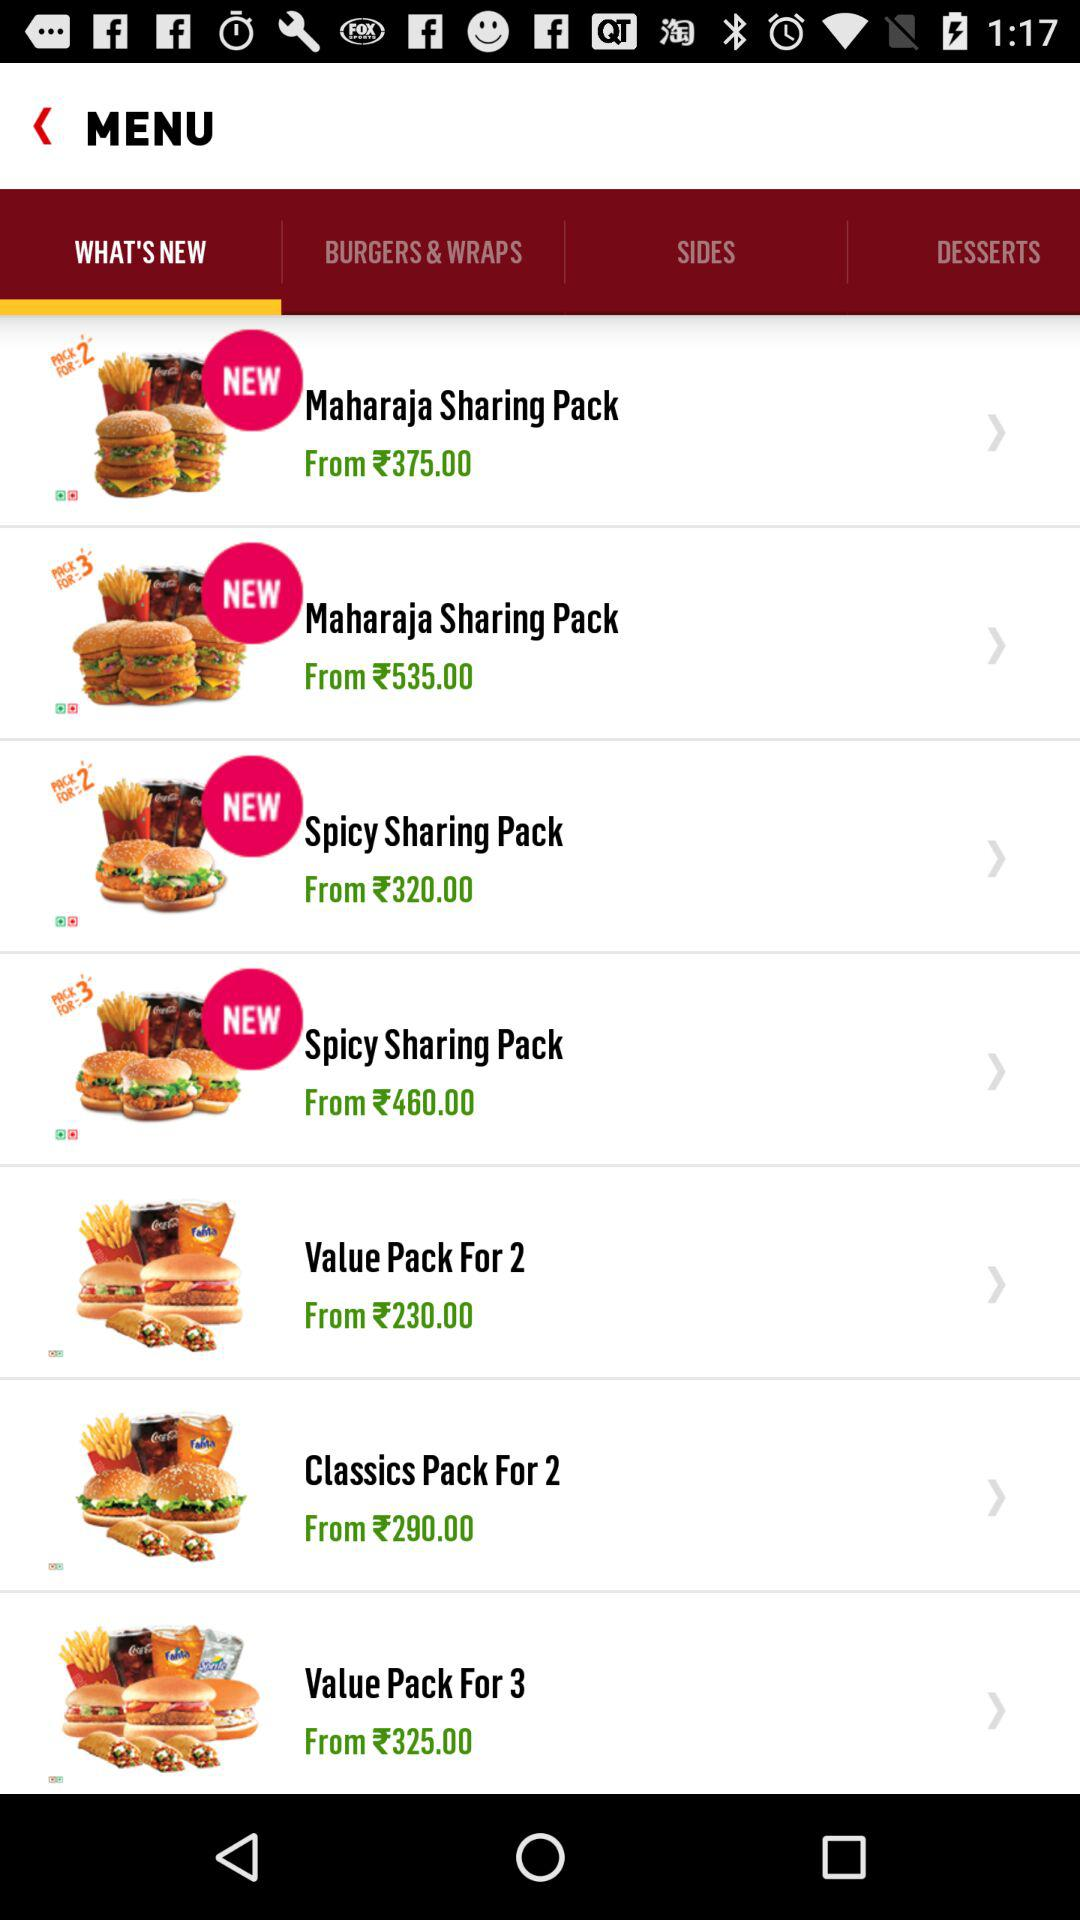How many Maharaja Sharing Pack items are on the menu?
Answer the question using a single word or phrase. 2 